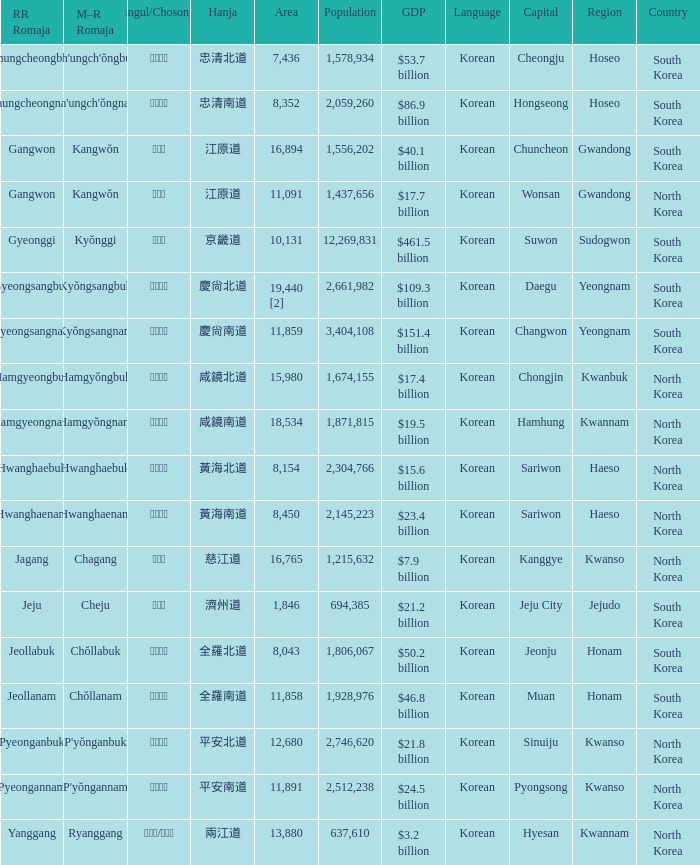What is the M-R Romaja for the province having a capital of Cheongju? Ch'ungch'ŏngbuk. 